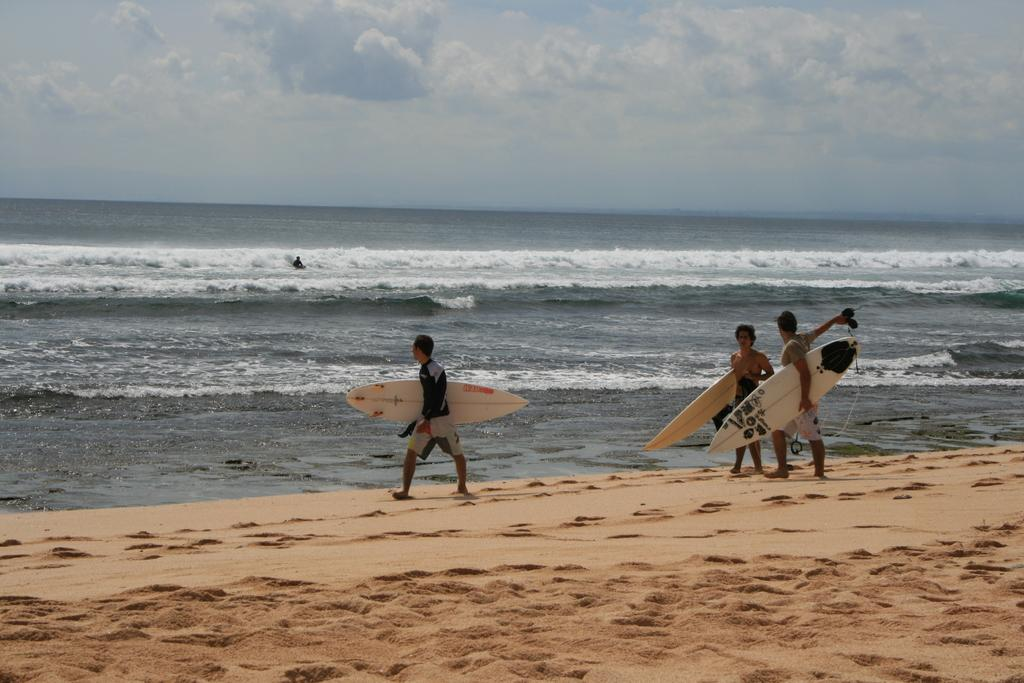How many people are in the image? There are three people in the image. What are the people holding in the image? The people are holding rowboats. Where are the people standing in the image? The people are standing on the sand. What is the location of the sand in relation to the sea? The sand is near the sea. What type of competition is taking place between the men in the image? There are no men mentioned in the image, and no competition is taking place. Can you tell me the temperature of the oven in the image? There is no oven present in the image. 